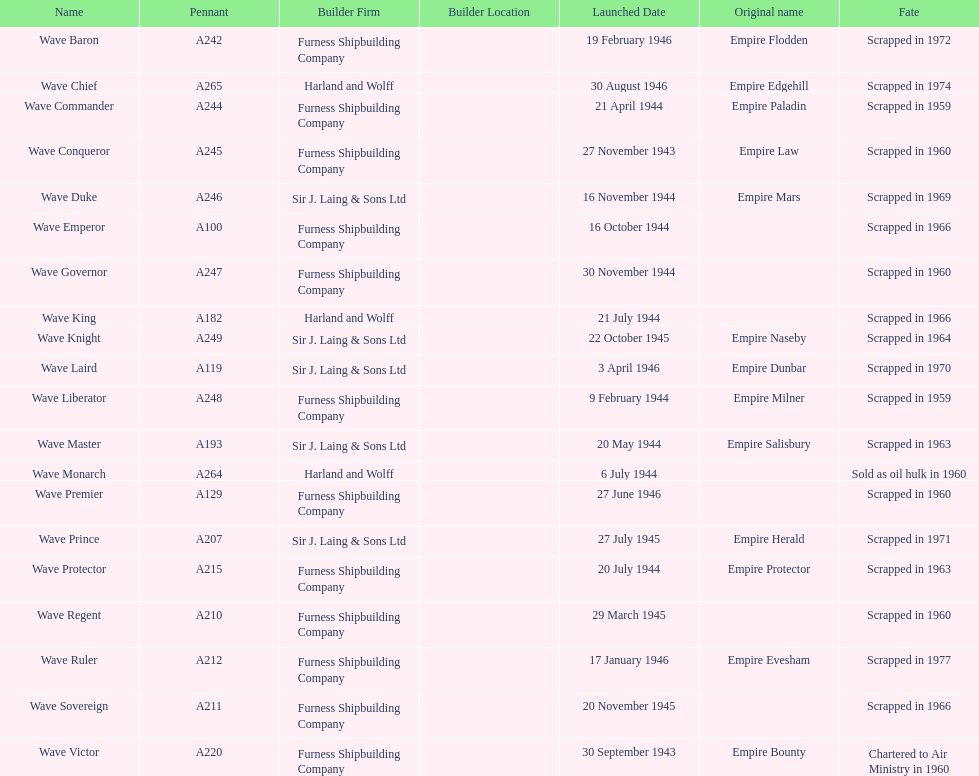How many ships were launched in the year 1944? 9. 